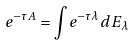Convert formula to latex. <formula><loc_0><loc_0><loc_500><loc_500>e ^ { - \tau A } = \int e ^ { - \tau \lambda } d E _ { \lambda }</formula> 